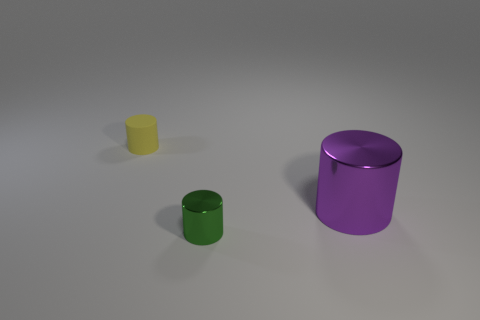Is there anything else that has the same size as the purple cylinder?
Provide a succinct answer. No. Are the object in front of the purple object and the large purple cylinder made of the same material?
Make the answer very short. Yes. Are there an equal number of metal cylinders behind the small yellow matte object and cylinders that are on the left side of the large purple metal cylinder?
Offer a very short reply. No. What shape is the object that is to the left of the purple metal object and behind the tiny shiny thing?
Your answer should be very brief. Cylinder. There is a green thing; how many small metallic objects are behind it?
Ensure brevity in your answer.  0. Are there fewer big purple metal cylinders than tiny objects?
Offer a very short reply. Yes. There is a thing that is both on the left side of the purple object and on the right side of the tiny yellow rubber cylinder; what size is it?
Offer a very short reply. Small. What size is the cylinder on the left side of the thing that is in front of the metal cylinder that is behind the tiny shiny object?
Offer a very short reply. Small. The purple metallic object is what size?
Provide a succinct answer. Large. Is there anything else that has the same material as the yellow cylinder?
Give a very brief answer. No. 